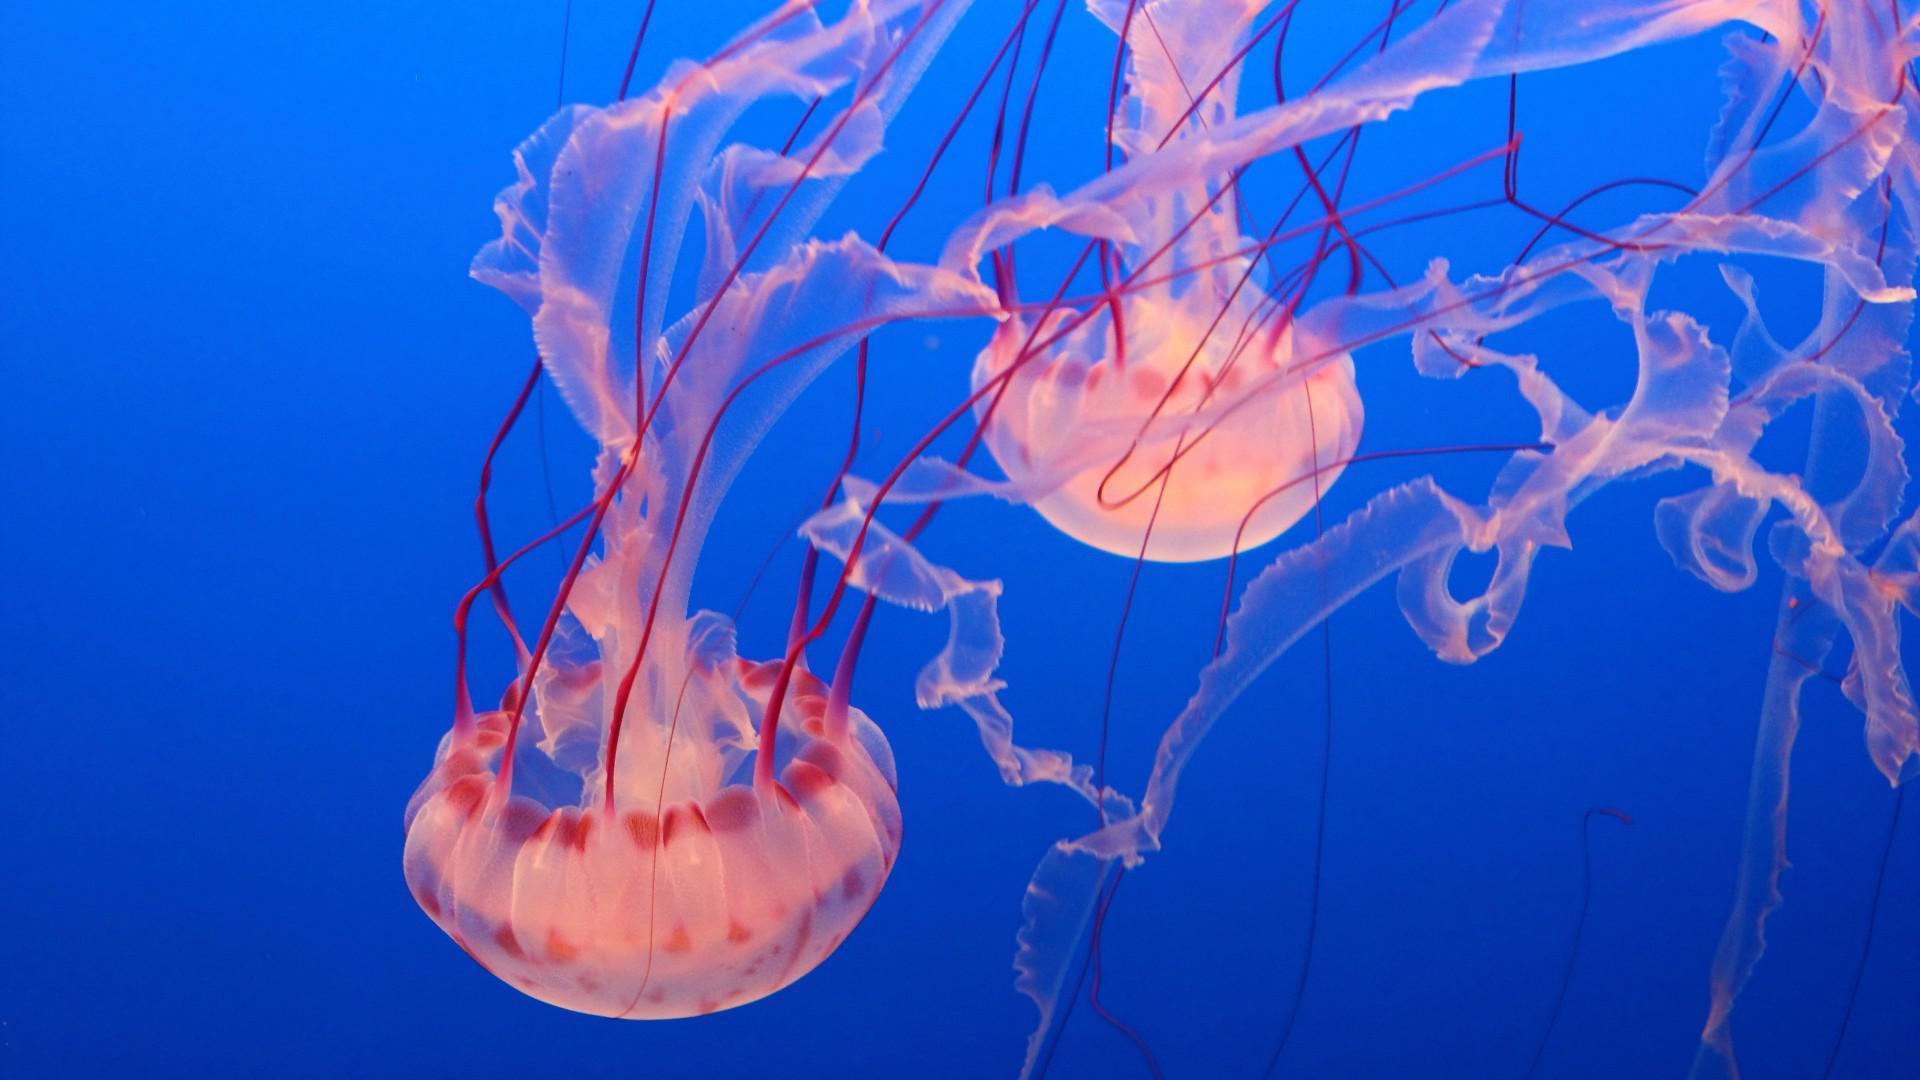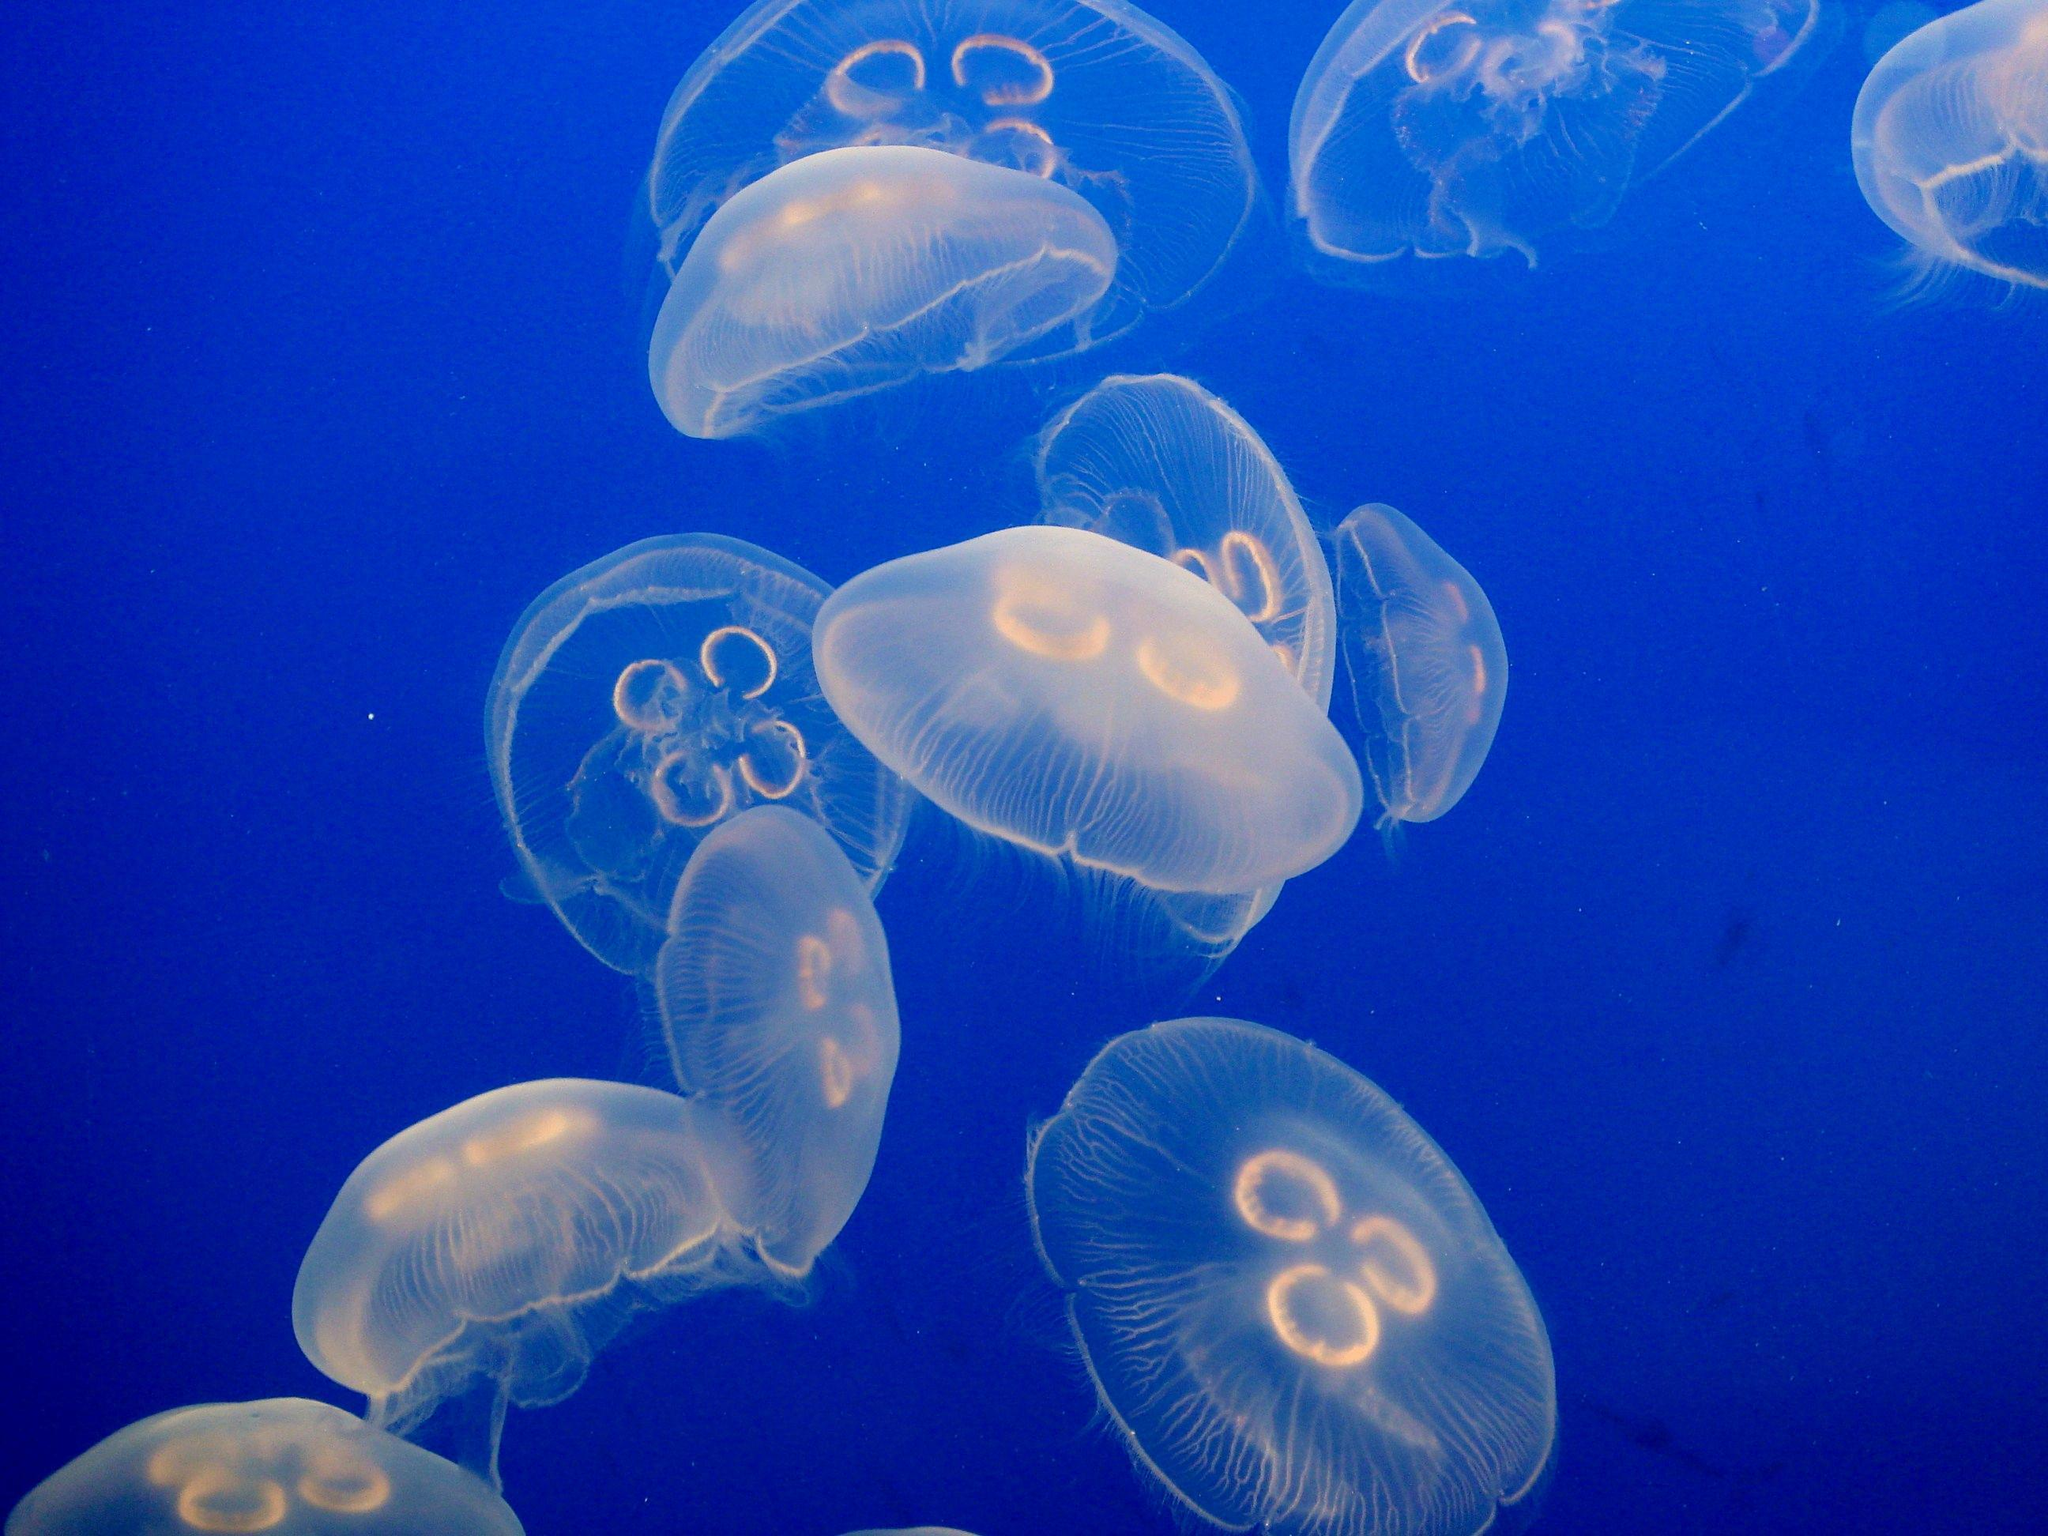The first image is the image on the left, the second image is the image on the right. Assess this claim about the two images: "In at least one image there is a circle jellyfish with its head looking like a four leaf clover.". Correct or not? Answer yes or no. Yes. The first image is the image on the left, the second image is the image on the right. For the images displayed, is the sentence "In one image at least one jellyfish is upside down." factually correct? Answer yes or no. Yes. 